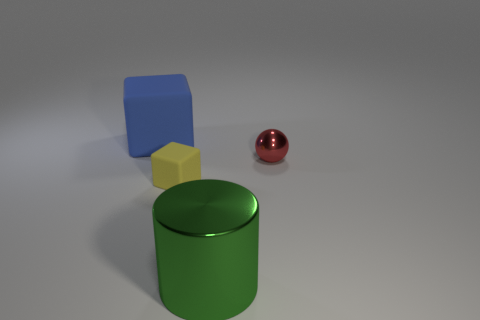Add 3 green metallic objects. How many objects exist? 7 Subtract all cylinders. How many objects are left? 3 Subtract all yellow rubber blocks. Subtract all big blue rubber cubes. How many objects are left? 2 Add 3 tiny things. How many tiny things are left? 5 Add 4 small brown rubber balls. How many small brown rubber balls exist? 4 Subtract 0 gray cylinders. How many objects are left? 4 